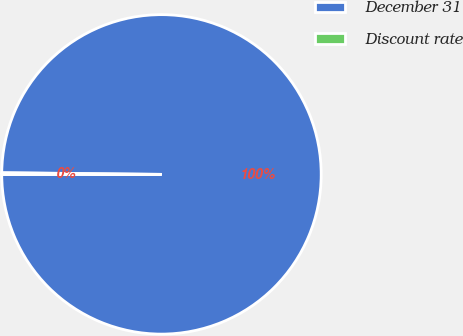Convert chart to OTSL. <chart><loc_0><loc_0><loc_500><loc_500><pie_chart><fcel>December 31<fcel>Discount rate<nl><fcel>99.82%<fcel>0.18%<nl></chart> 